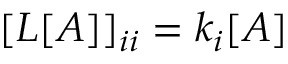<formula> <loc_0><loc_0><loc_500><loc_500>[ L [ A ] ] _ { i i } = k _ { i } [ A ]</formula> 